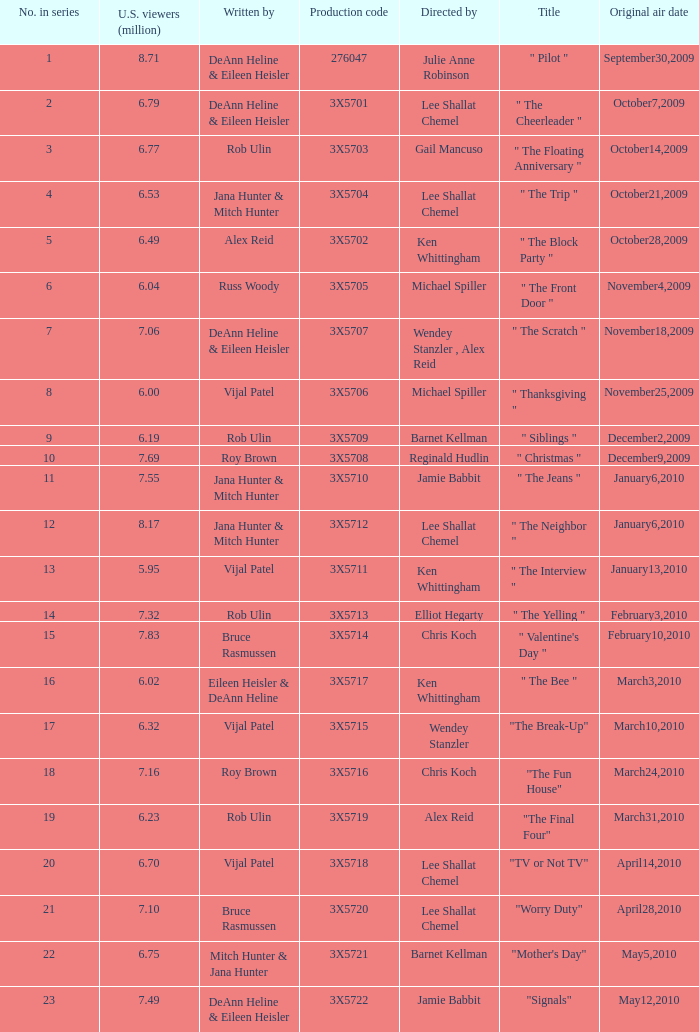How many million U.S. viewers saw the episode with production code 3X5710? 7.55. 